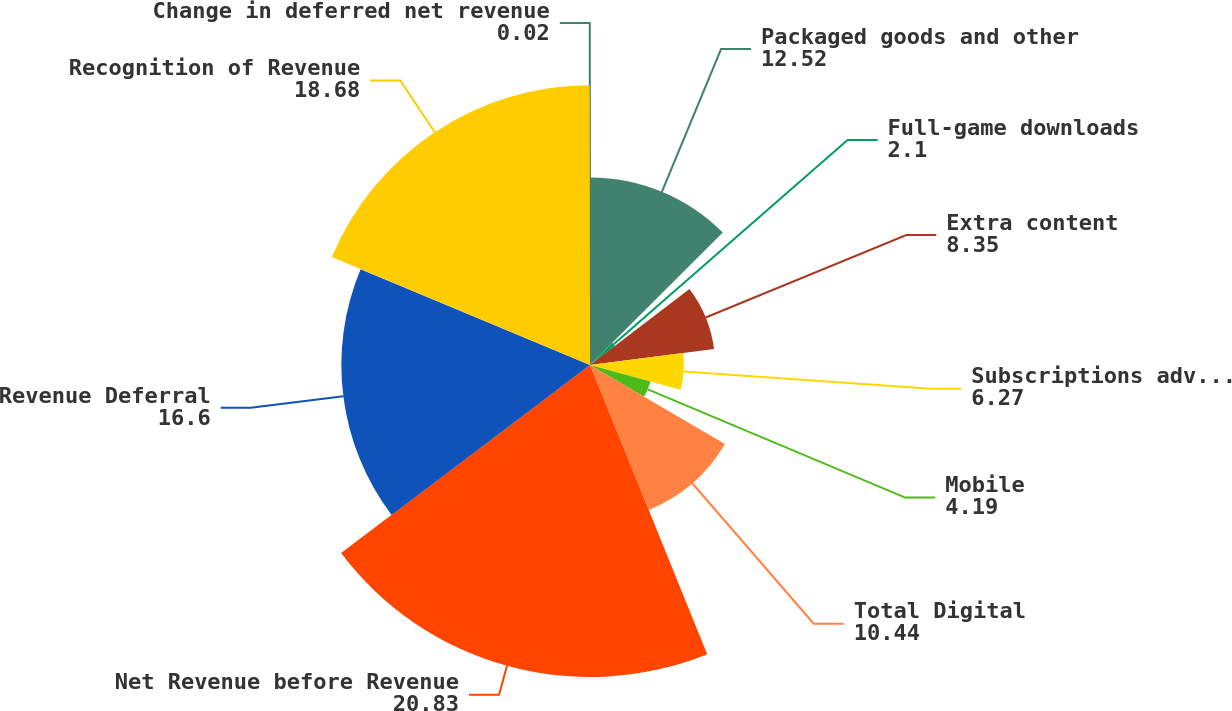Convert chart to OTSL. <chart><loc_0><loc_0><loc_500><loc_500><pie_chart><fcel>Packaged goods and other<fcel>Full-game downloads<fcel>Extra content<fcel>Subscriptions advertising and<fcel>Mobile<fcel>Total Digital<fcel>Net Revenue before Revenue<fcel>Revenue Deferral<fcel>Recognition of Revenue<fcel>Change in deferred net revenue<nl><fcel>12.52%<fcel>2.1%<fcel>8.35%<fcel>6.27%<fcel>4.19%<fcel>10.44%<fcel>20.83%<fcel>16.6%<fcel>18.68%<fcel>0.02%<nl></chart> 